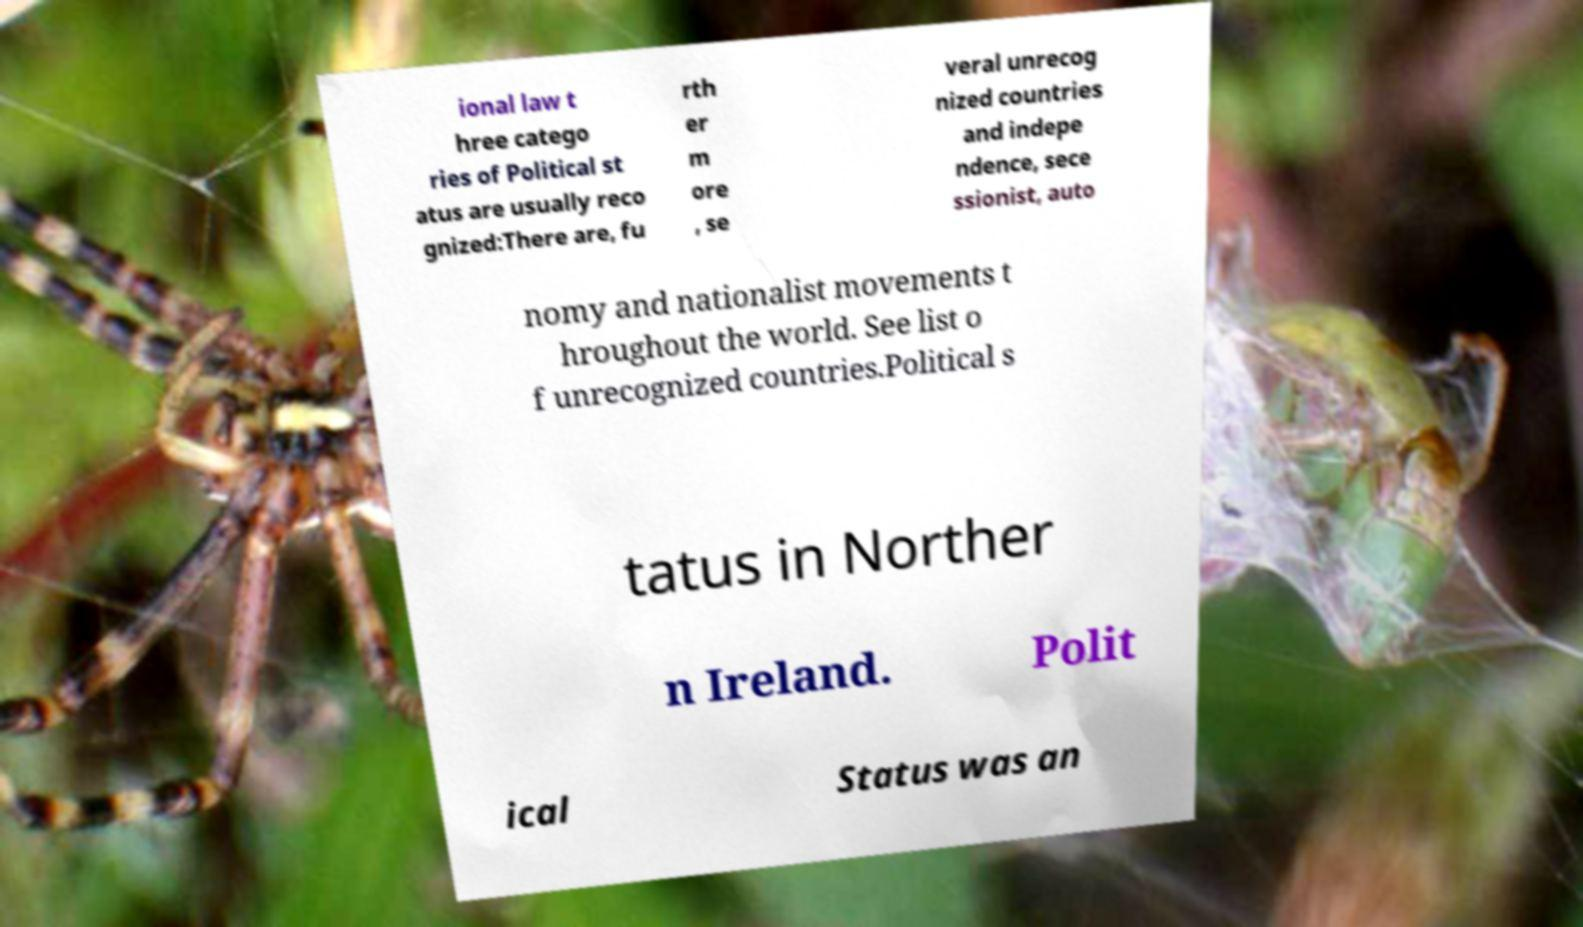Please read and relay the text visible in this image. What does it say? ional law t hree catego ries of Political st atus are usually reco gnized:There are, fu rth er m ore , se veral unrecog nized countries and indepe ndence, sece ssionist, auto nomy and nationalist movements t hroughout the world. See list o f unrecognized countries.Political s tatus in Norther n Ireland. Polit ical Status was an 